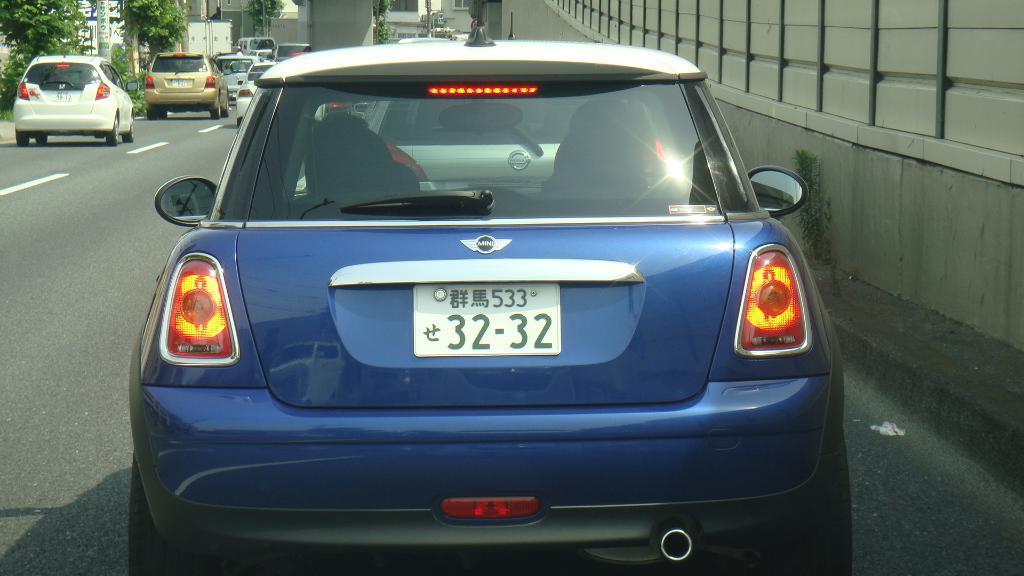How would you summarize this image in a sentence or two? In the image in the center we can see few vehicles on the road. In the background we can see trees,buildings,poles,banners etc. 